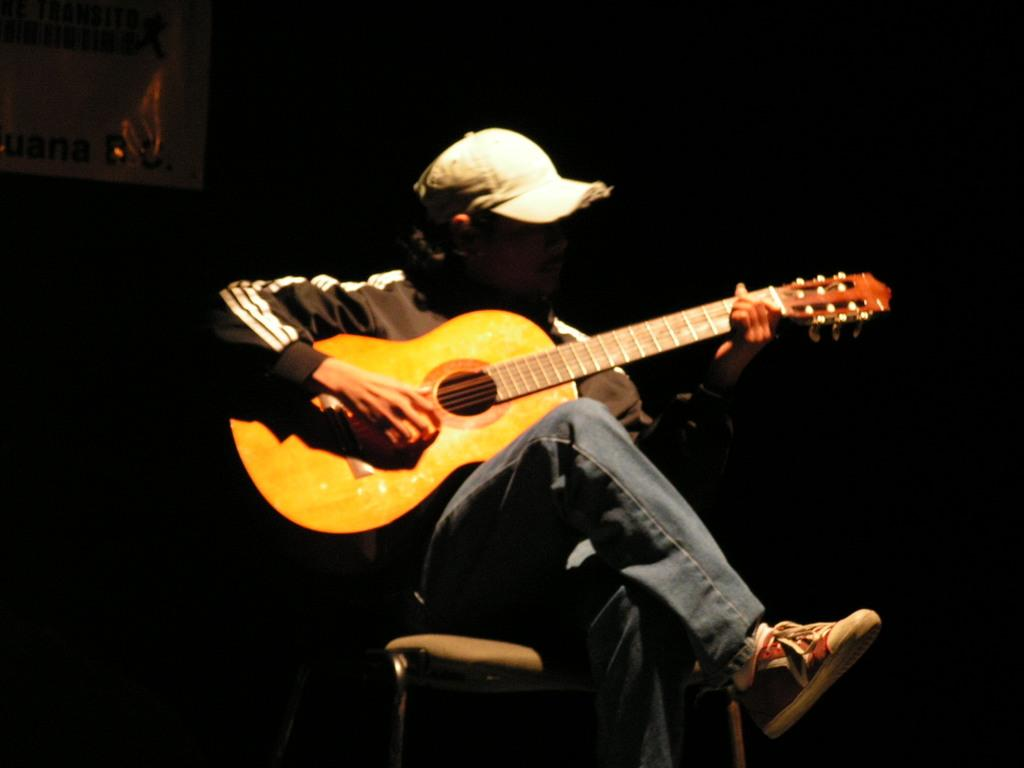What is the main subject of the image? There is a person in the image. What is the person wearing? The person is wearing a black jacket. What is the person doing in the image? The person is sitting in a chair and playing a guitar. What is the color of the background in the image? The background of the image is black in color. How many cows can be seen grazing near the seashore in the image? There are no cows or seashore present in the image; it features a person playing a guitar with a black background. 